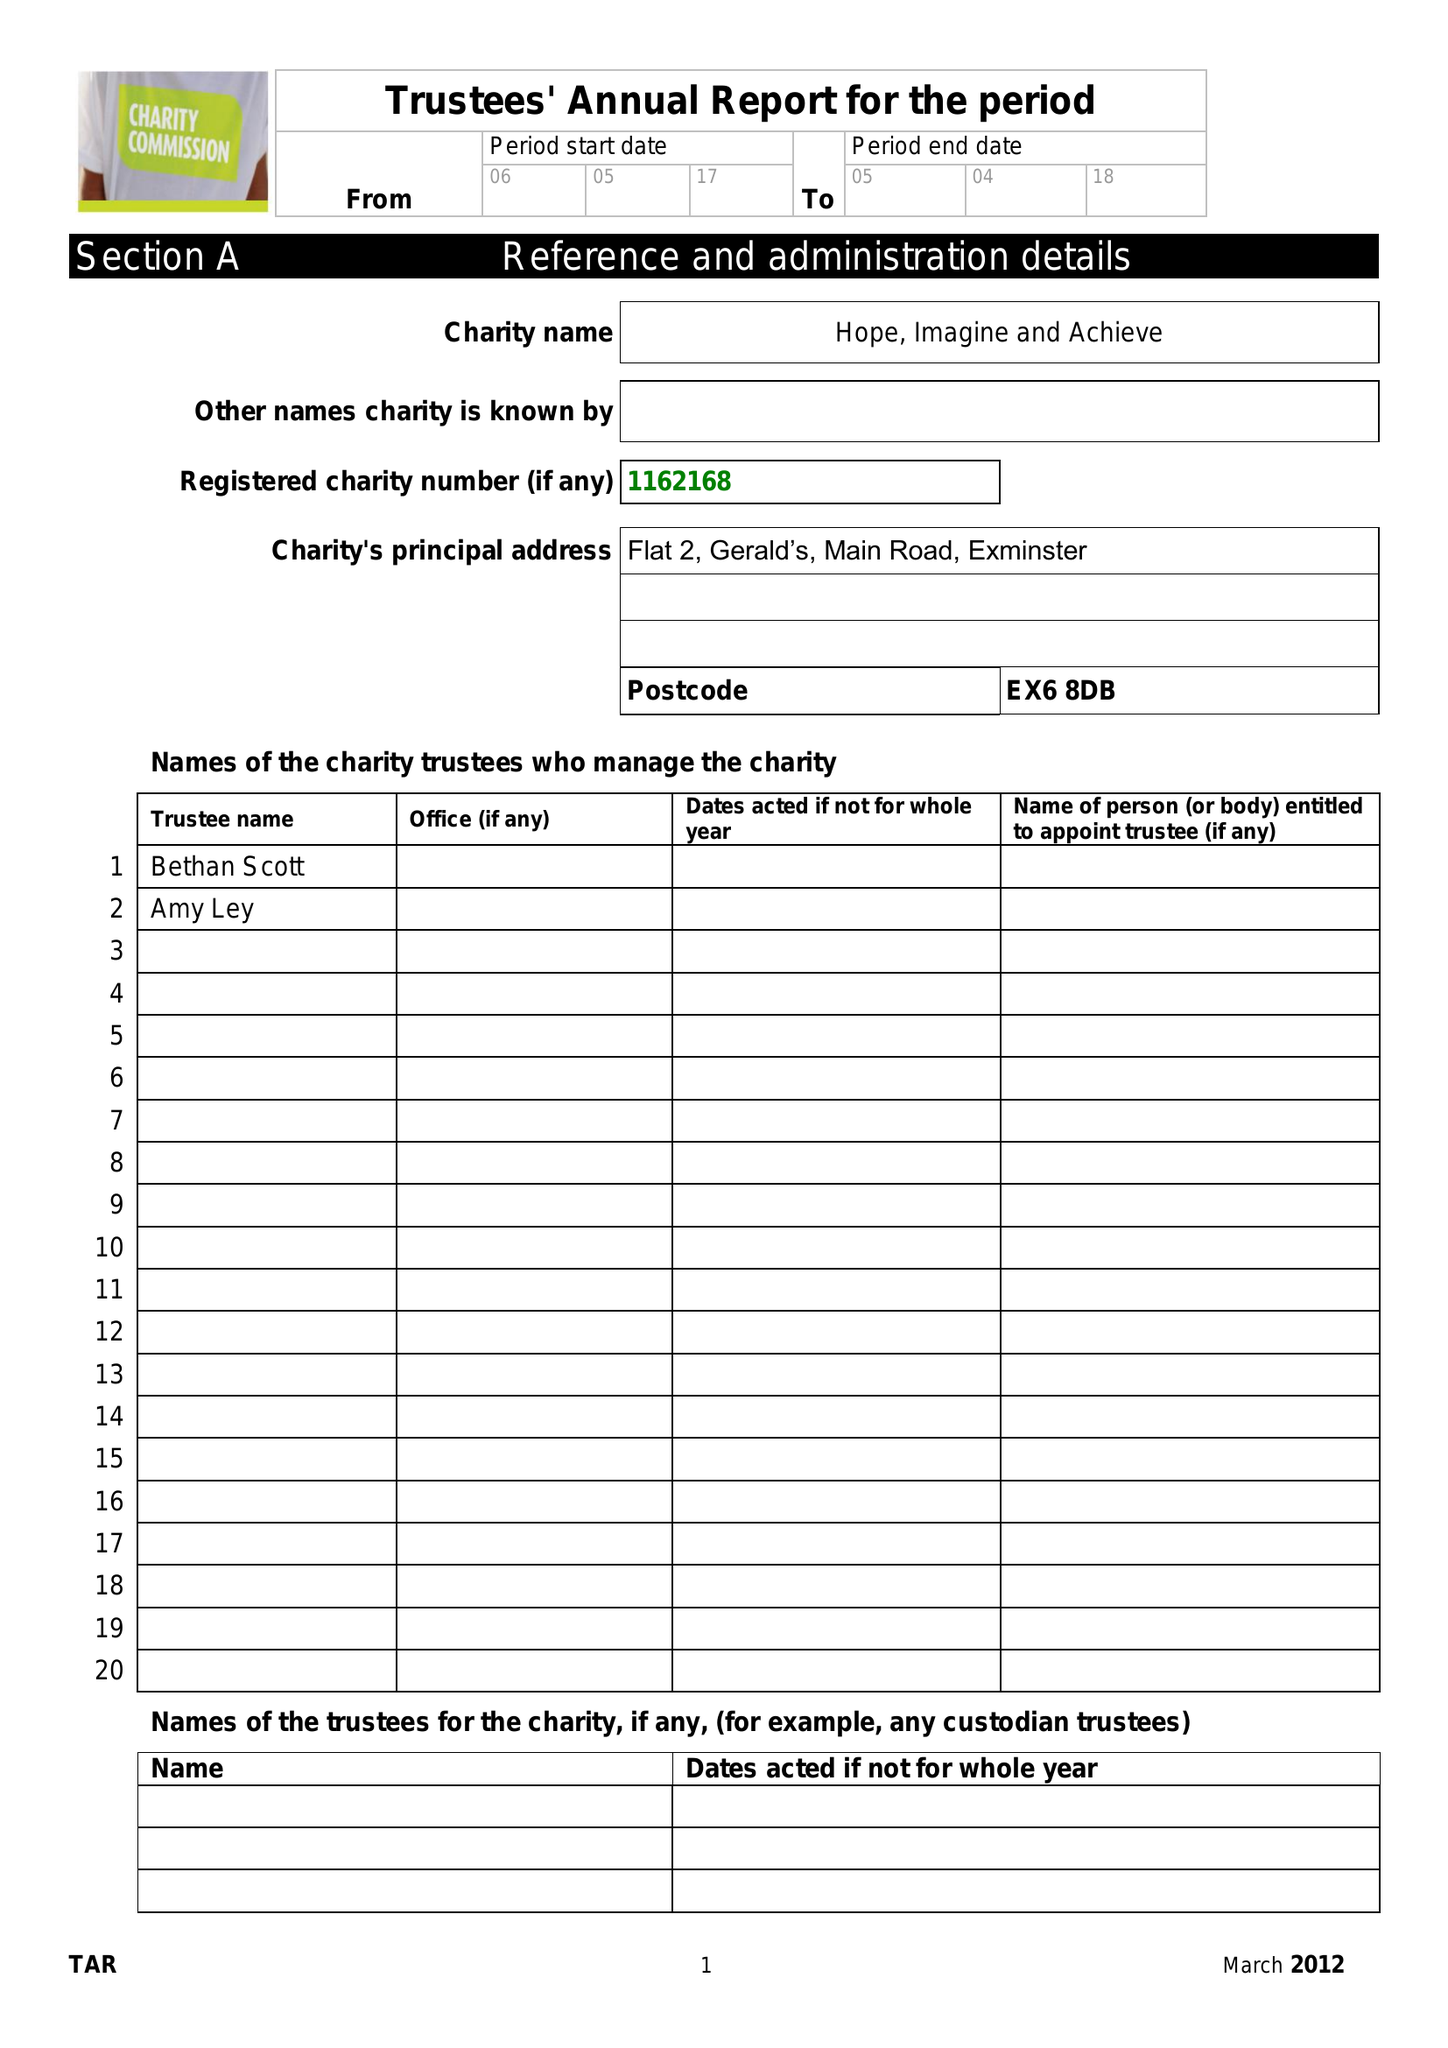What is the value for the charity_name?
Answer the question using a single word or phrase. Hope, Imagine and Achieve 